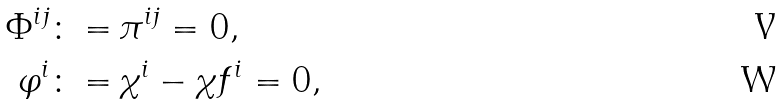<formula> <loc_0><loc_0><loc_500><loc_500>\Phi ^ { i j } \colon = & \, \pi ^ { i j } = 0 , \\ \varphi ^ { i } \colon = & \, \chi ^ { i } - \chi f ^ { i } = 0 ,</formula> 